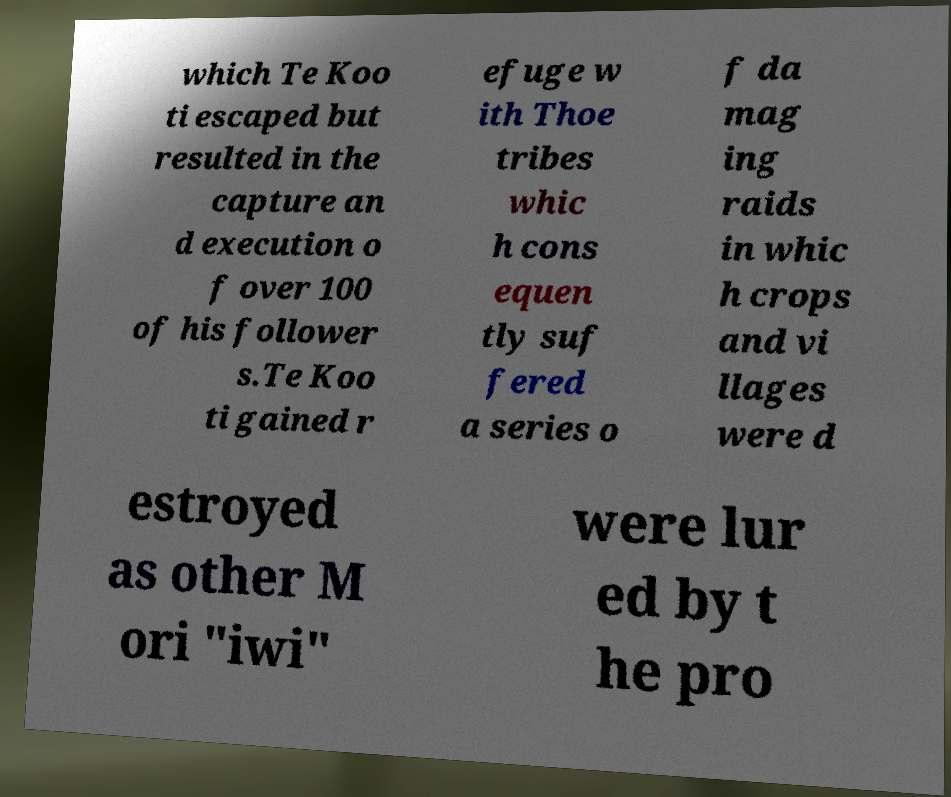There's text embedded in this image that I need extracted. Can you transcribe it verbatim? which Te Koo ti escaped but resulted in the capture an d execution o f over 100 of his follower s.Te Koo ti gained r efuge w ith Thoe tribes whic h cons equen tly suf fered a series o f da mag ing raids in whic h crops and vi llages were d estroyed as other M ori "iwi" were lur ed by t he pro 